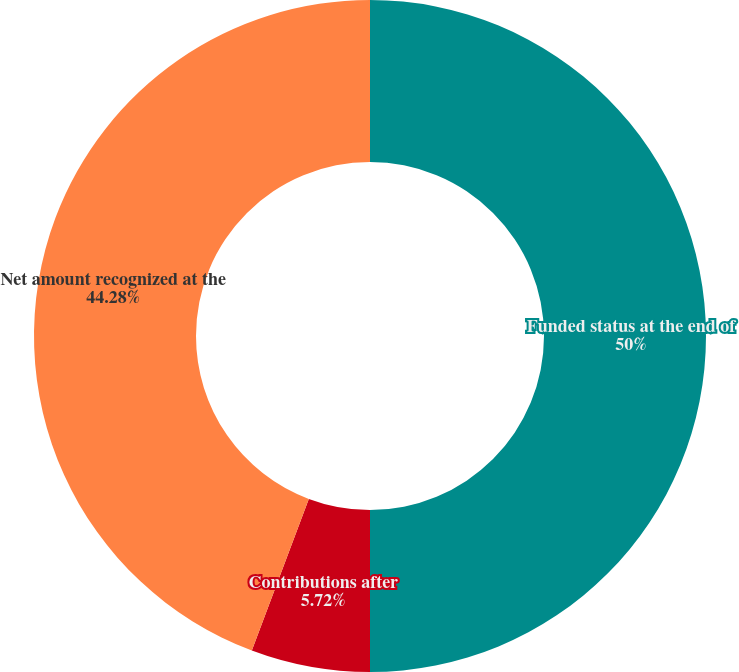Convert chart to OTSL. <chart><loc_0><loc_0><loc_500><loc_500><pie_chart><fcel>Funded status at the end of<fcel>Contributions after<fcel>Net amount recognized at the<nl><fcel>50.0%<fcel>5.72%<fcel>44.28%<nl></chart> 